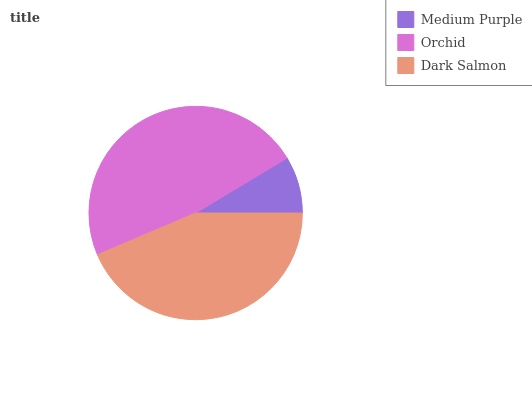Is Medium Purple the minimum?
Answer yes or no. Yes. Is Orchid the maximum?
Answer yes or no. Yes. Is Dark Salmon the minimum?
Answer yes or no. No. Is Dark Salmon the maximum?
Answer yes or no. No. Is Orchid greater than Dark Salmon?
Answer yes or no. Yes. Is Dark Salmon less than Orchid?
Answer yes or no. Yes. Is Dark Salmon greater than Orchid?
Answer yes or no. No. Is Orchid less than Dark Salmon?
Answer yes or no. No. Is Dark Salmon the high median?
Answer yes or no. Yes. Is Dark Salmon the low median?
Answer yes or no. Yes. Is Medium Purple the high median?
Answer yes or no. No. Is Orchid the low median?
Answer yes or no. No. 